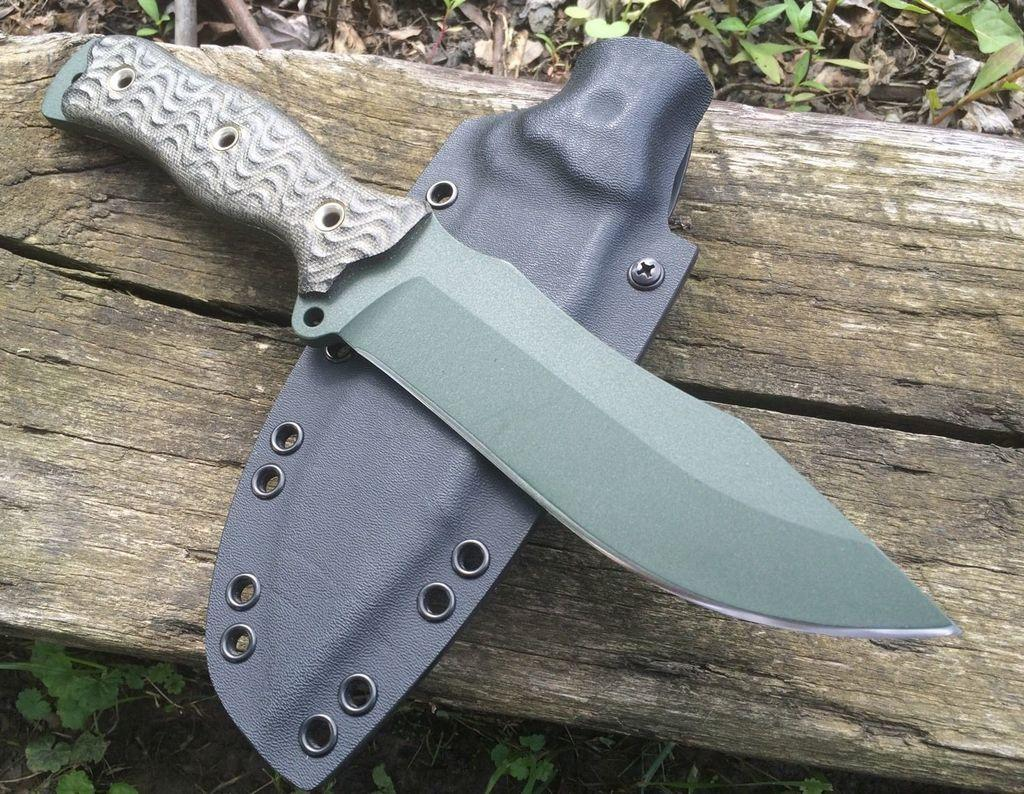What type of object is present in the image that is typically used for cutting? There is a knife in the image. Is there any protective covering for the knife in the image? Yes, there is a knife bag in the image. On what surface are the knife and knife bag placed? The knife and knife bag are placed on a wooden board. What type of vegetation can be seen in the image? There are plants visible in the image. What type of poison is being used to look at the rule in the image? There is no poison, looking, or rule present in the image. 